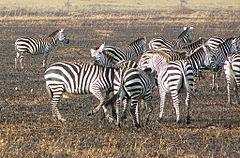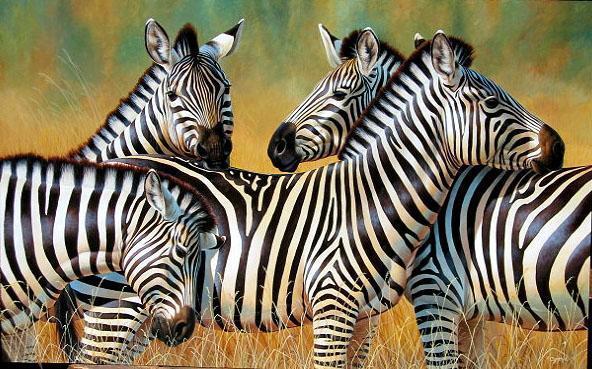The first image is the image on the left, the second image is the image on the right. Examine the images to the left and right. Is the description "The image on the right has two or fewer zebras." accurate? Answer yes or no. No. The first image is the image on the left, the second image is the image on the right. Given the left and right images, does the statement "No image contains fewer that three zebras, and the left image includes rear-turned zebras in the foreground." hold true? Answer yes or no. Yes. 